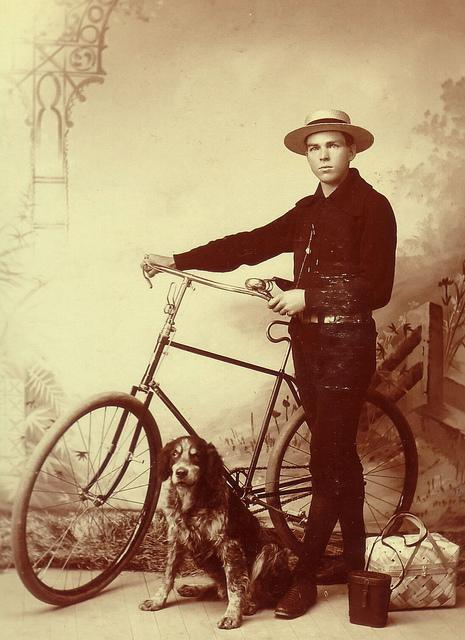What purpose is the bike serving right now?

Choices:
A) exercise
B) prop
C) travel
D) commerce prop 